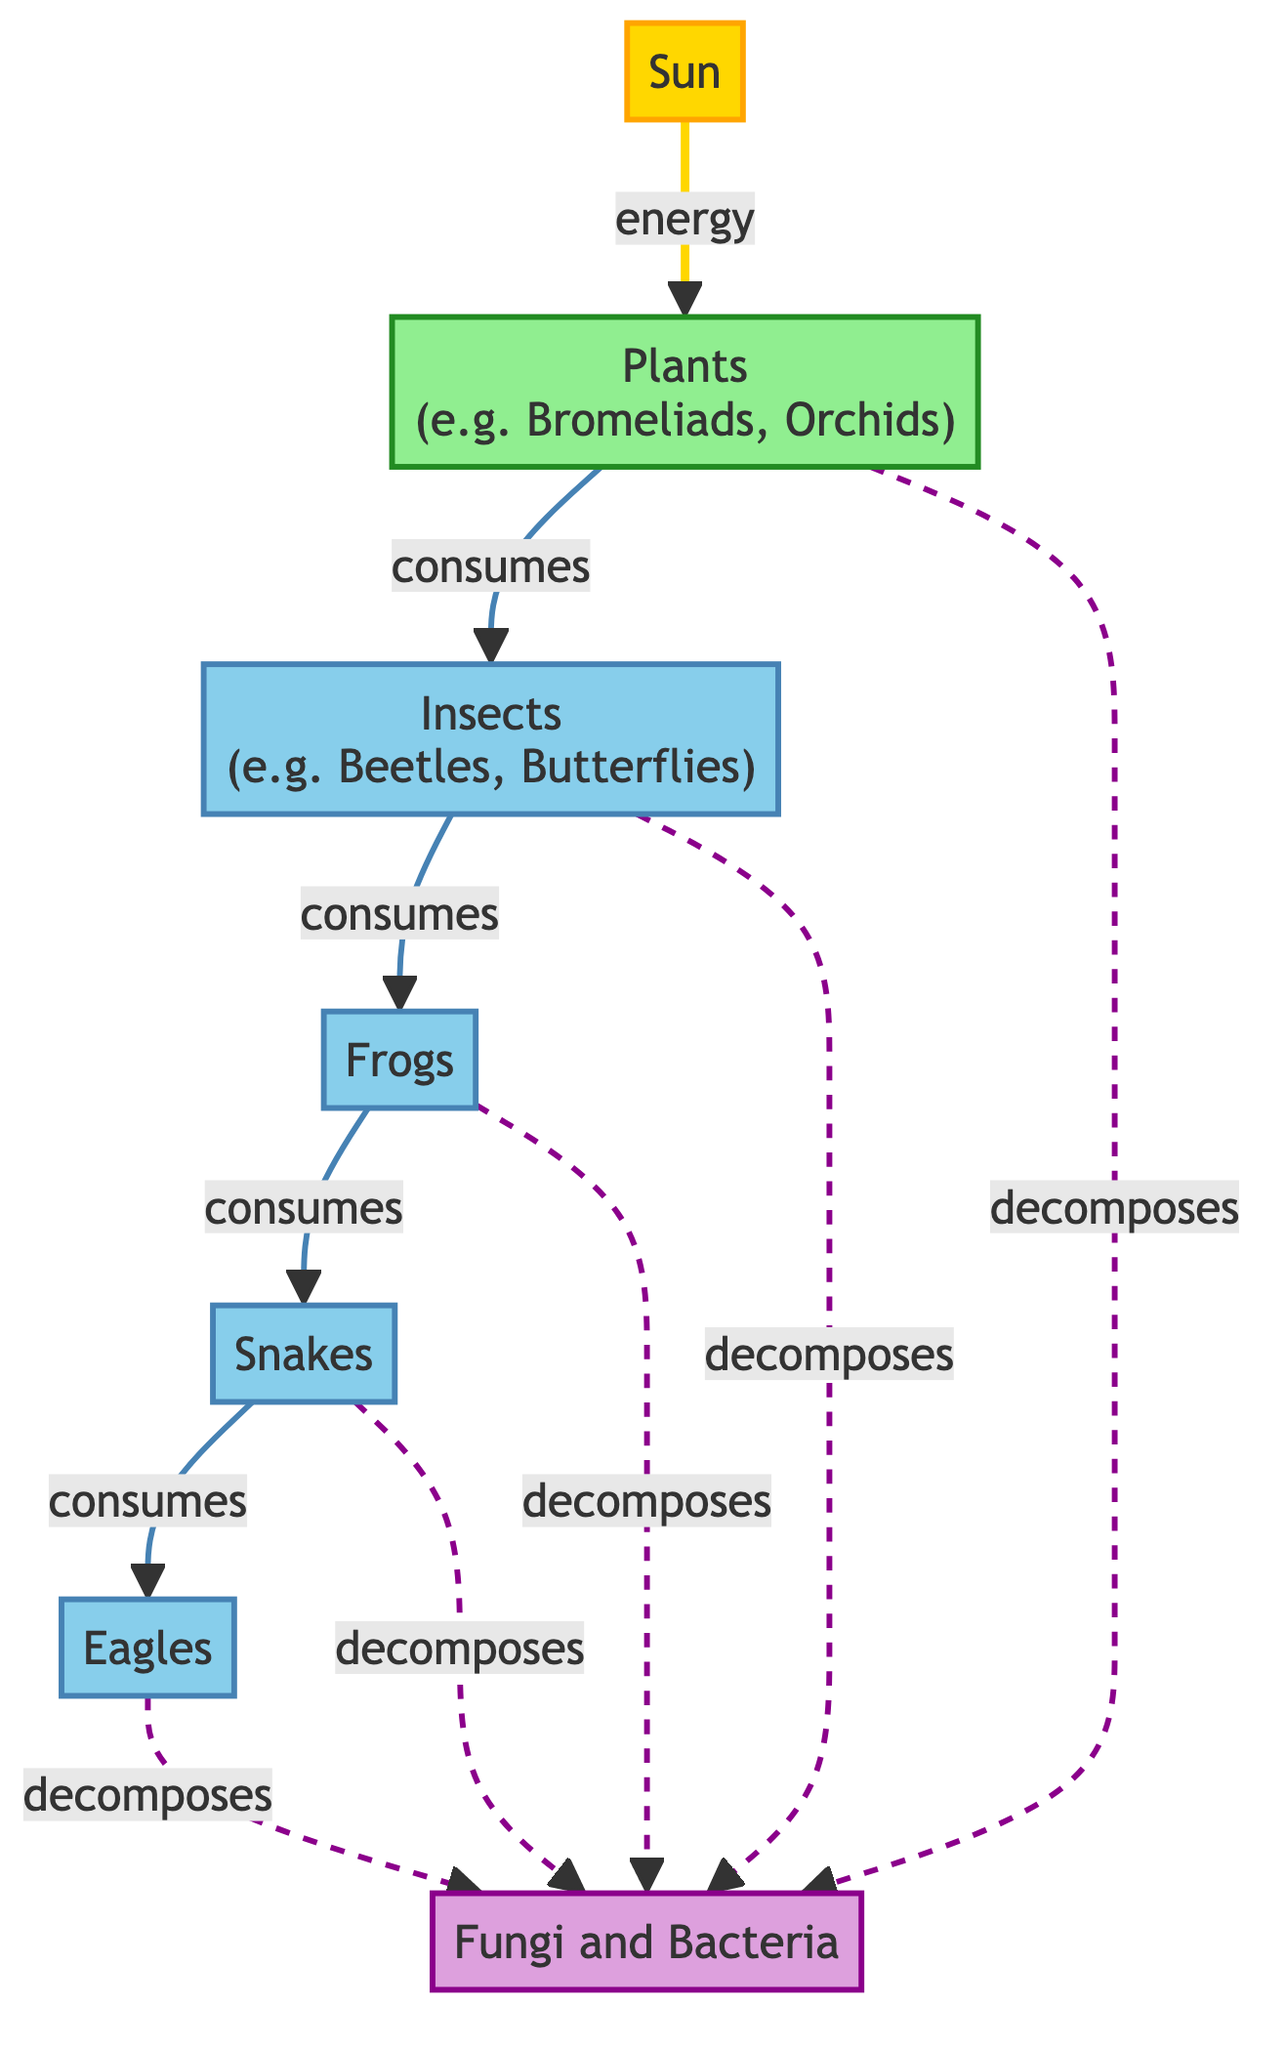What is the primary source of energy in the food web? The diagram shows the "Sun" as the main energy source, represented by an arrow pointing toward "Plants". This indicates that energy flows from the Sun to the producers, which is a fundamental concept in food webs.
Answer: Sun How many consumer types are represented in the diagram? By examining the nodes in the diagram, we can identify four consumer types: Insects, Frogs, Snakes, and Eagles. Therefore, there are four distinct consumer categories indicated.
Answer: 4 What do plants consume in the food web? The diagram indicates that "Plants" are consumed by "Insects", which is shown by the direct arrow from the "Plants" node pointing to the "Insects" node. Hence, plants serve as a food source for insects.
Answer: Insects Which consumer is at the top of the food chain in this food web? Analyzing the flow from lower consumers to higher ones reveals that "Eagles" are positioned above the other consumers, consuming "Snakes", which places them at the top of this food chain.
Answer: Eagles What role do fungi and bacteria serve in the food web? In the diagram, fungi and bacteria are shown to be decomposers as indicated by their classification and the dashed line connections from various consumers and producers, illustrating their role in breaking down organic material after death.
Answer: Decomposers What is the relationship between snakes and eagles in terms of consumption? The diagram demonstrates a direct arrow from "Snakes" to "Eagles", indicating that snakes are consumed by eagles. This connection signifies a predator-prey relationship.
Answer: Snakes How many decomposers are illustrated in the diagram? A review of the diagram shows that "Fungi and Bacteria" is the only decomposer represented. Therefore, there is only one type of decomposer in the food web.
Answer: 1 What is the connection type between the consumers and fungi? The diagram uses dashed lines to connect all consumer nodes to "Fungi and Bacteria", indicating that the relationship signifies decomposition rather than direct consumption.
Answer: Decomposes 